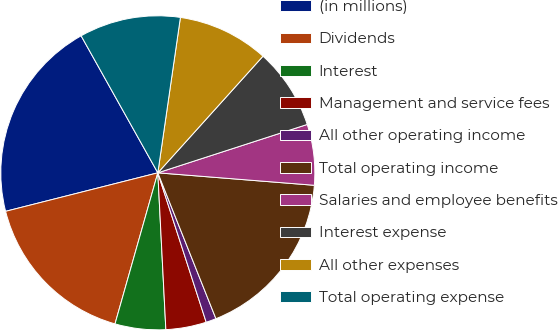Convert chart. <chart><loc_0><loc_0><loc_500><loc_500><pie_chart><fcel>(in millions)<fcel>Dividends<fcel>Interest<fcel>Management and service fees<fcel>All other operating income<fcel>Total operating income<fcel>Salaries and employee benefits<fcel>Interest expense<fcel>All other expenses<fcel>Total operating expense<nl><fcel>20.82%<fcel>16.66%<fcel>5.21%<fcel>4.17%<fcel>1.05%<fcel>17.7%<fcel>6.25%<fcel>8.34%<fcel>9.38%<fcel>10.42%<nl></chart> 